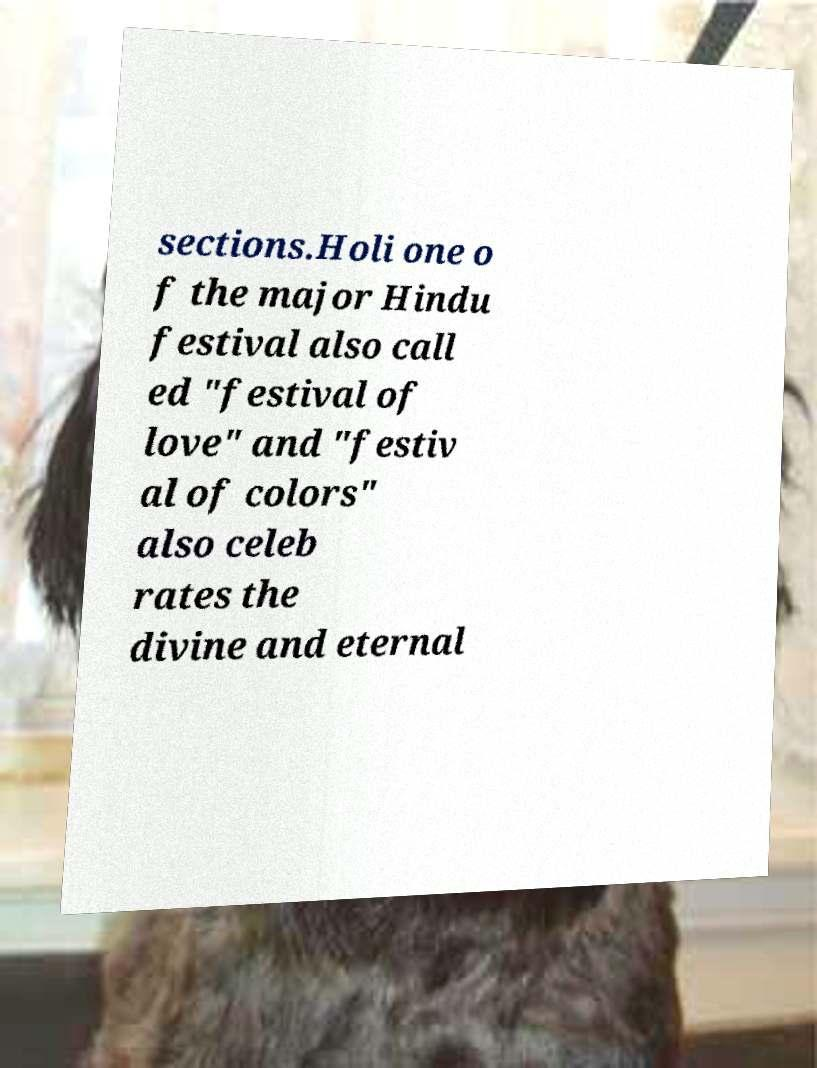What messages or text are displayed in this image? I need them in a readable, typed format. sections.Holi one o f the major Hindu festival also call ed "festival of love" and "festiv al of colors" also celeb rates the divine and eternal 